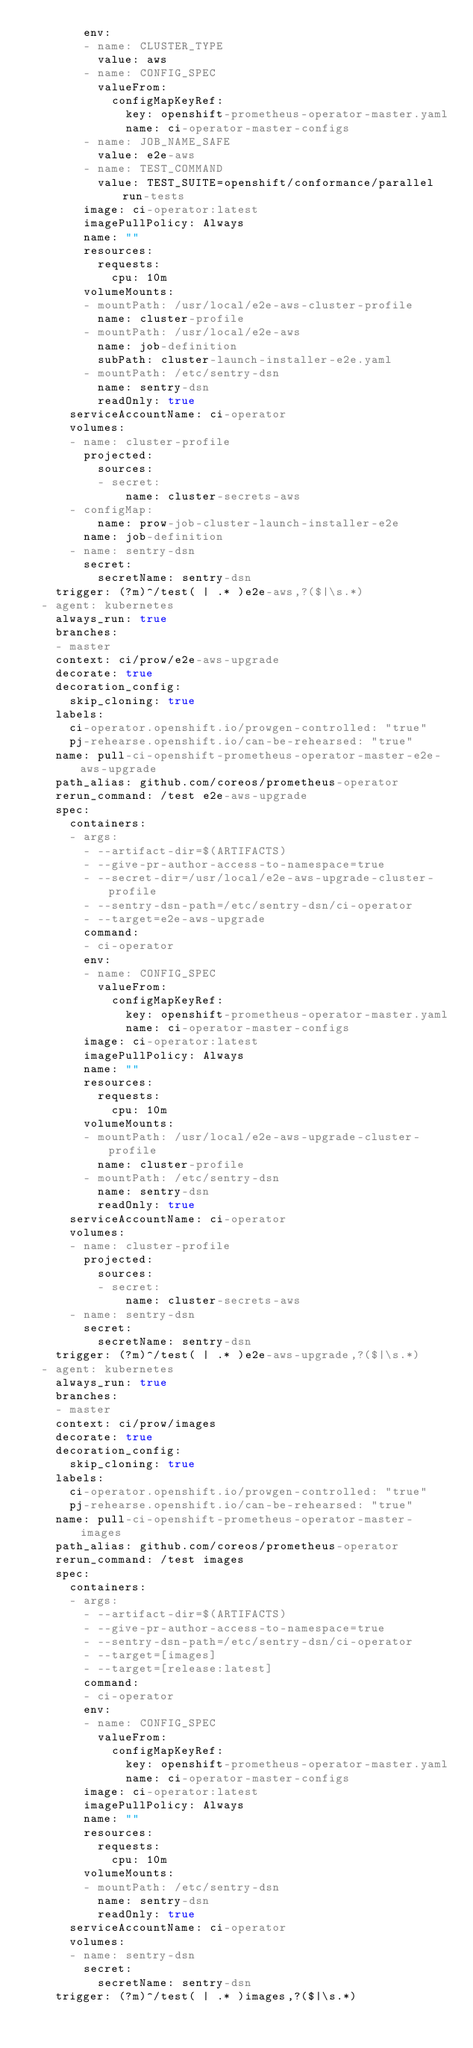<code> <loc_0><loc_0><loc_500><loc_500><_YAML_>        env:
        - name: CLUSTER_TYPE
          value: aws
        - name: CONFIG_SPEC
          valueFrom:
            configMapKeyRef:
              key: openshift-prometheus-operator-master.yaml
              name: ci-operator-master-configs
        - name: JOB_NAME_SAFE
          value: e2e-aws
        - name: TEST_COMMAND
          value: TEST_SUITE=openshift/conformance/parallel run-tests
        image: ci-operator:latest
        imagePullPolicy: Always
        name: ""
        resources:
          requests:
            cpu: 10m
        volumeMounts:
        - mountPath: /usr/local/e2e-aws-cluster-profile
          name: cluster-profile
        - mountPath: /usr/local/e2e-aws
          name: job-definition
          subPath: cluster-launch-installer-e2e.yaml
        - mountPath: /etc/sentry-dsn
          name: sentry-dsn
          readOnly: true
      serviceAccountName: ci-operator
      volumes:
      - name: cluster-profile
        projected:
          sources:
          - secret:
              name: cluster-secrets-aws
      - configMap:
          name: prow-job-cluster-launch-installer-e2e
        name: job-definition
      - name: sentry-dsn
        secret:
          secretName: sentry-dsn
    trigger: (?m)^/test( | .* )e2e-aws,?($|\s.*)
  - agent: kubernetes
    always_run: true
    branches:
    - master
    context: ci/prow/e2e-aws-upgrade
    decorate: true
    decoration_config:
      skip_cloning: true
    labels:
      ci-operator.openshift.io/prowgen-controlled: "true"
      pj-rehearse.openshift.io/can-be-rehearsed: "true"
    name: pull-ci-openshift-prometheus-operator-master-e2e-aws-upgrade
    path_alias: github.com/coreos/prometheus-operator
    rerun_command: /test e2e-aws-upgrade
    spec:
      containers:
      - args:
        - --artifact-dir=$(ARTIFACTS)
        - --give-pr-author-access-to-namespace=true
        - --secret-dir=/usr/local/e2e-aws-upgrade-cluster-profile
        - --sentry-dsn-path=/etc/sentry-dsn/ci-operator
        - --target=e2e-aws-upgrade
        command:
        - ci-operator
        env:
        - name: CONFIG_SPEC
          valueFrom:
            configMapKeyRef:
              key: openshift-prometheus-operator-master.yaml
              name: ci-operator-master-configs
        image: ci-operator:latest
        imagePullPolicy: Always
        name: ""
        resources:
          requests:
            cpu: 10m
        volumeMounts:
        - mountPath: /usr/local/e2e-aws-upgrade-cluster-profile
          name: cluster-profile
        - mountPath: /etc/sentry-dsn
          name: sentry-dsn
          readOnly: true
      serviceAccountName: ci-operator
      volumes:
      - name: cluster-profile
        projected:
          sources:
          - secret:
              name: cluster-secrets-aws
      - name: sentry-dsn
        secret:
          secretName: sentry-dsn
    trigger: (?m)^/test( | .* )e2e-aws-upgrade,?($|\s.*)
  - agent: kubernetes
    always_run: true
    branches:
    - master
    context: ci/prow/images
    decorate: true
    decoration_config:
      skip_cloning: true
    labels:
      ci-operator.openshift.io/prowgen-controlled: "true"
      pj-rehearse.openshift.io/can-be-rehearsed: "true"
    name: pull-ci-openshift-prometheus-operator-master-images
    path_alias: github.com/coreos/prometheus-operator
    rerun_command: /test images
    spec:
      containers:
      - args:
        - --artifact-dir=$(ARTIFACTS)
        - --give-pr-author-access-to-namespace=true
        - --sentry-dsn-path=/etc/sentry-dsn/ci-operator
        - --target=[images]
        - --target=[release:latest]
        command:
        - ci-operator
        env:
        - name: CONFIG_SPEC
          valueFrom:
            configMapKeyRef:
              key: openshift-prometheus-operator-master.yaml
              name: ci-operator-master-configs
        image: ci-operator:latest
        imagePullPolicy: Always
        name: ""
        resources:
          requests:
            cpu: 10m
        volumeMounts:
        - mountPath: /etc/sentry-dsn
          name: sentry-dsn
          readOnly: true
      serviceAccountName: ci-operator
      volumes:
      - name: sentry-dsn
        secret:
          secretName: sentry-dsn
    trigger: (?m)^/test( | .* )images,?($|\s.*)
</code> 